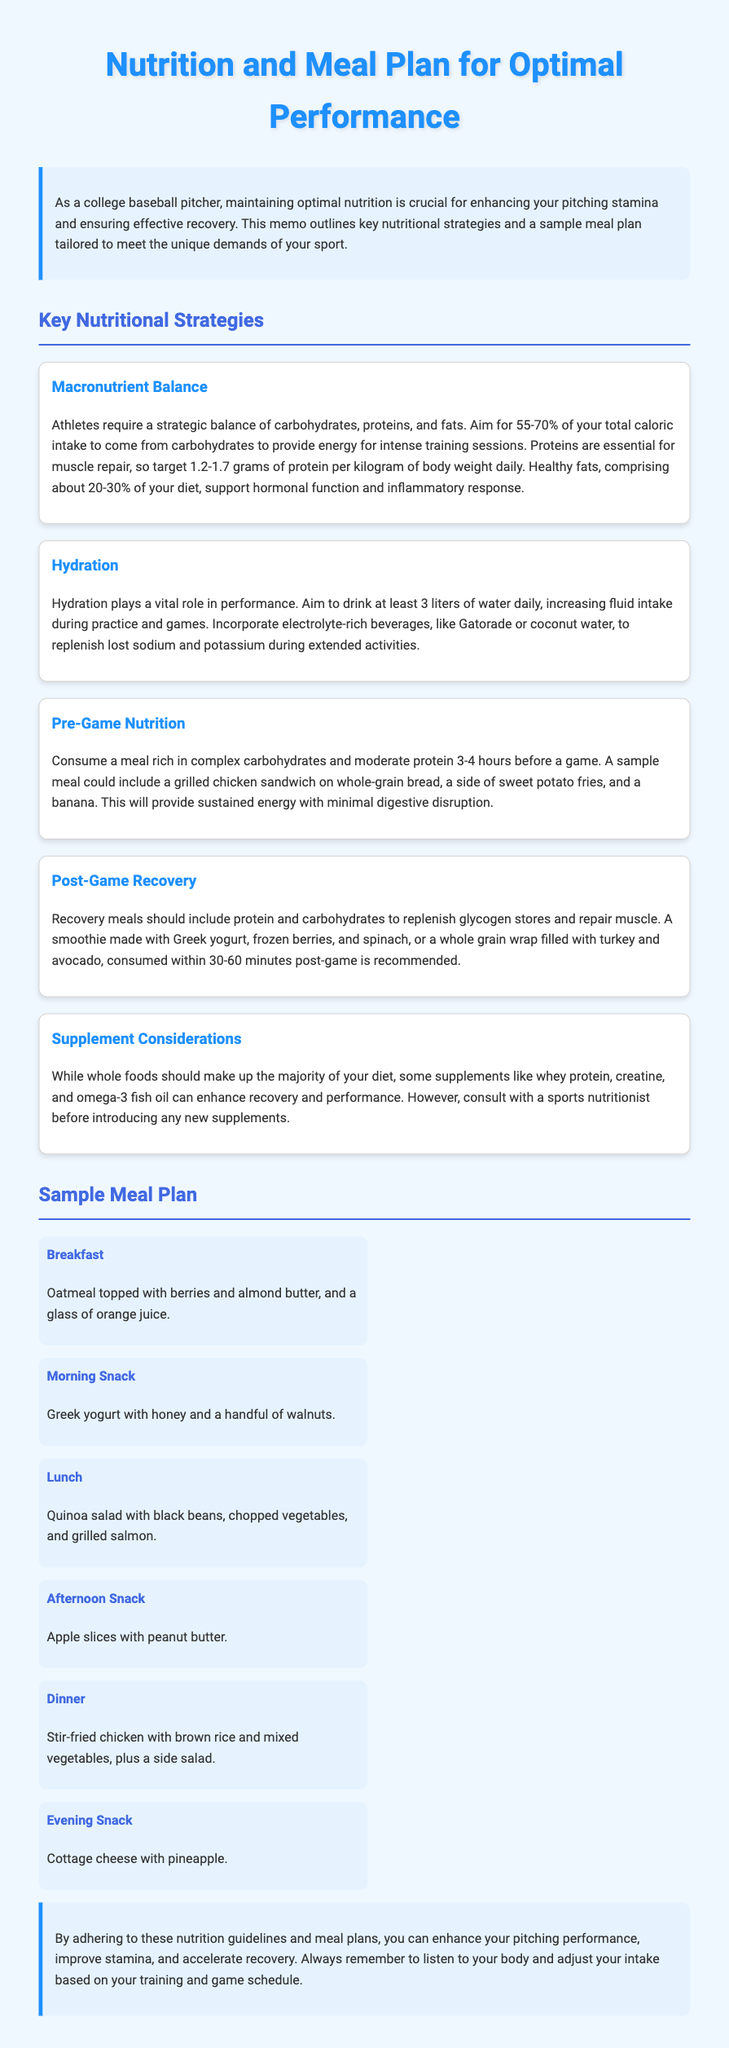What should 55-70% of total caloric intake come from? The document states that 55-70% of total caloric intake should come from carbohydrates.
Answer: Carbohydrates How many liters of water should athletes aim to drink daily? The memo specifies that athletes should aim to drink at least 3 liters of water daily.
Answer: 3 liters What is a sample pre-game meal suggested in the memo? The document suggests a grilled chicken sandwich on whole-grain bread, a side of sweet potato fries, and a banana as a pre-game meal.
Answer: Grilled chicken sandwich What macronutrient is crucial for muscle repair? According to the memo, proteins are essential for muscle repair.
Answer: Proteins How long before a game should a pre-game meal be consumed? The memo indicates that a pre-game meal should be consumed 3-4 hours before a game.
Answer: 3-4 hours What are the key components of a post-game recovery meal? The document mentions that recovery meals should include protein and carbohydrates to replenish glycogen stores and repair muscle.
Answer: Protein and carbohydrates What type of meal is suggested for breakfast in the sample meal plan? The sample meal plan suggests oatmeal topped with berries and almond butter for breakfast.
Answer: Oatmeal with berries What percentage of the diet should healthy fats comprise? The document states that healthy fats should comprise about 20-30% of your diet.
Answer: 20-30% What is the role of hydration according to the memo? The memo mentions that hydration plays a vital role in performance.
Answer: Vital role in performance 